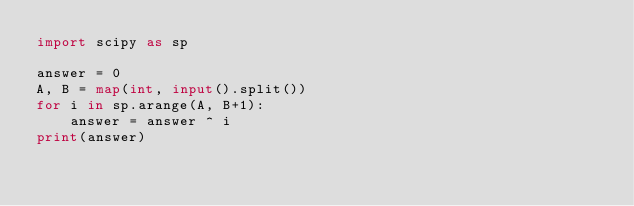Convert code to text. <code><loc_0><loc_0><loc_500><loc_500><_Python_>import scipy as sp

answer = 0
A, B = map(int, input().split()) 
for i in sp.arange(A, B+1):
    answer = answer ^ i
print(answer)</code> 